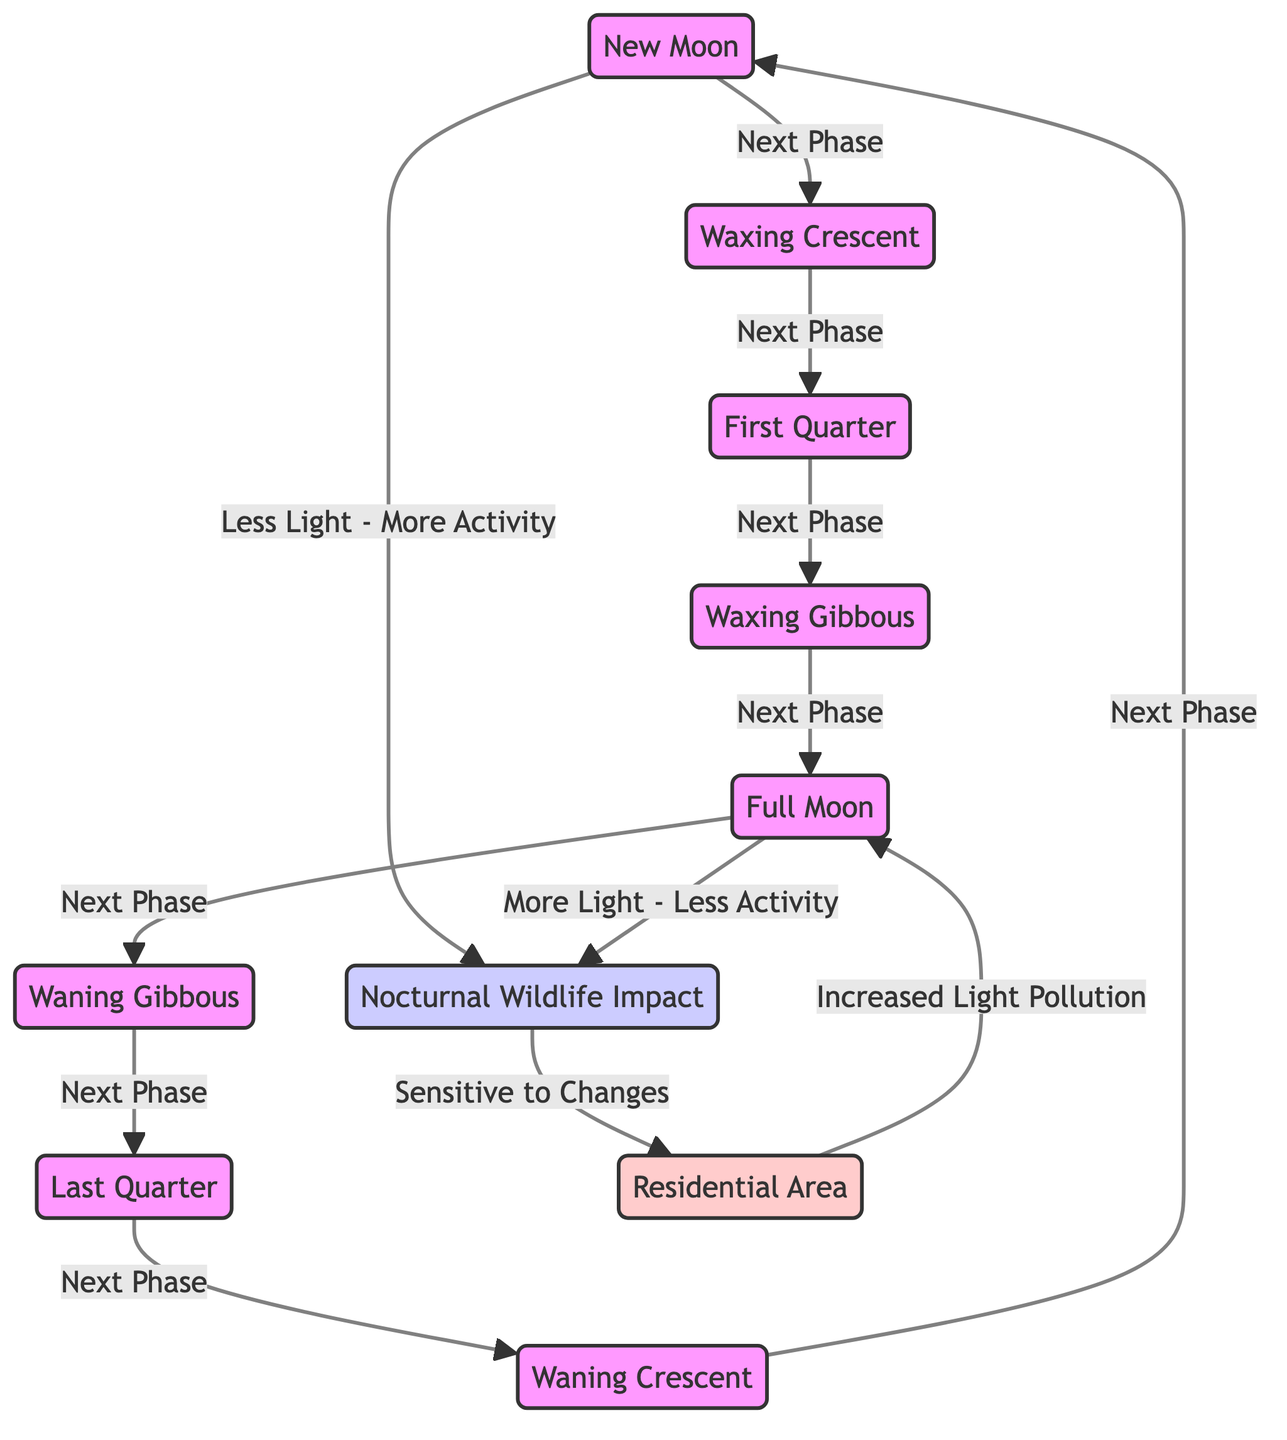What are the phases of the Moon listed in the diagram? The diagram shows eight distinct phases of the Moon: New Moon, Waxing Crescent, First Quarter, Waxing Gibbous, Full Moon, Waning Gibbous, Last Quarter, and Waning Crescent.
Answer: New Moon, Waxing Crescent, First Quarter, Waxing Gibbous, Full Moon, Waning Gibbous, Last Quarter, Waning Crescent How many connections are there from the New Moon phase to the next phases? The diagram illustrates that the New Moon connects to the Waxing Crescent, indicating there is one connection moving forward in the sequence of phases.
Answer: 1 What is the relationship between the Full Moon and nocturnal wildlife? According to the diagram, the Full Moon is associated with "More Light - Less Activity," which suggests that increased light from the Full Moon impacts wildlife activity negatively.
Answer: More Light - Less Activity What happens to nocturnal wildlife impact during a New Moon phase? The diagram states that during the New Moon phase, there is "Less Light - More Activity," indicating that wildlife is more active in dimmer conditions.
Answer: Less Light - More Activity How does increased light pollution affect residential areas during the Full Moon? The diagram indicates that the Full Moon contributes to "Increased Light Pollution," which is a concern for residential areas, as the light may disrupt the environment.
Answer: Increased Light Pollution What is the behavior of nocturnal wildlife in relation to sensitivity? The diagram links "Nocturnal Wildlife Impact" to "Sensitive to Changes," implying that wildlife is particularly responsive to varying light levels during different phases of the Moon.
Answer: Sensitive to Changes How many distinct phases are shown in the diagram that influence nocturnal wildlife? The diagram includes eight distinct Moon phases which may influence nocturnal wildlife behavior, as each phase has a corresponding impact on activity levels.
Answer: 8 What is the transition from the Waning Crescent back to a New Moon? The diagram illustrates a circular flow where after the Waning Crescent phase, it transitions back to the New Moon phase, showing the cyclical nature of lunar phases.
Answer: New Moon 